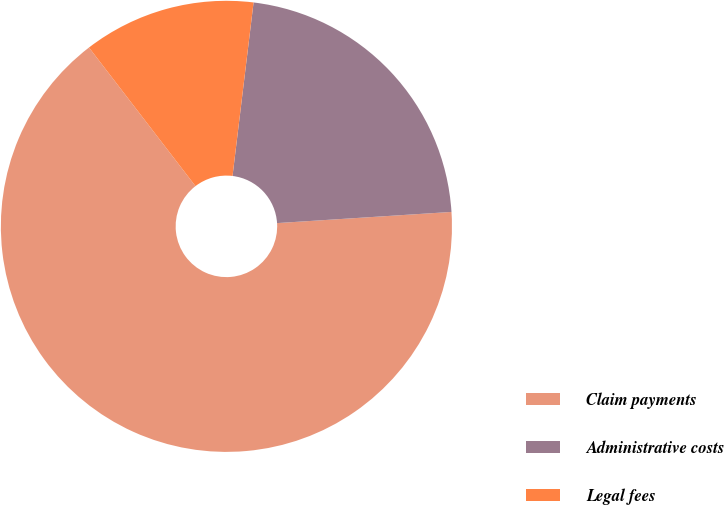<chart> <loc_0><loc_0><loc_500><loc_500><pie_chart><fcel>Claim payments<fcel>Administrative costs<fcel>Legal fees<nl><fcel>65.59%<fcel>22.06%<fcel>12.35%<nl></chart> 